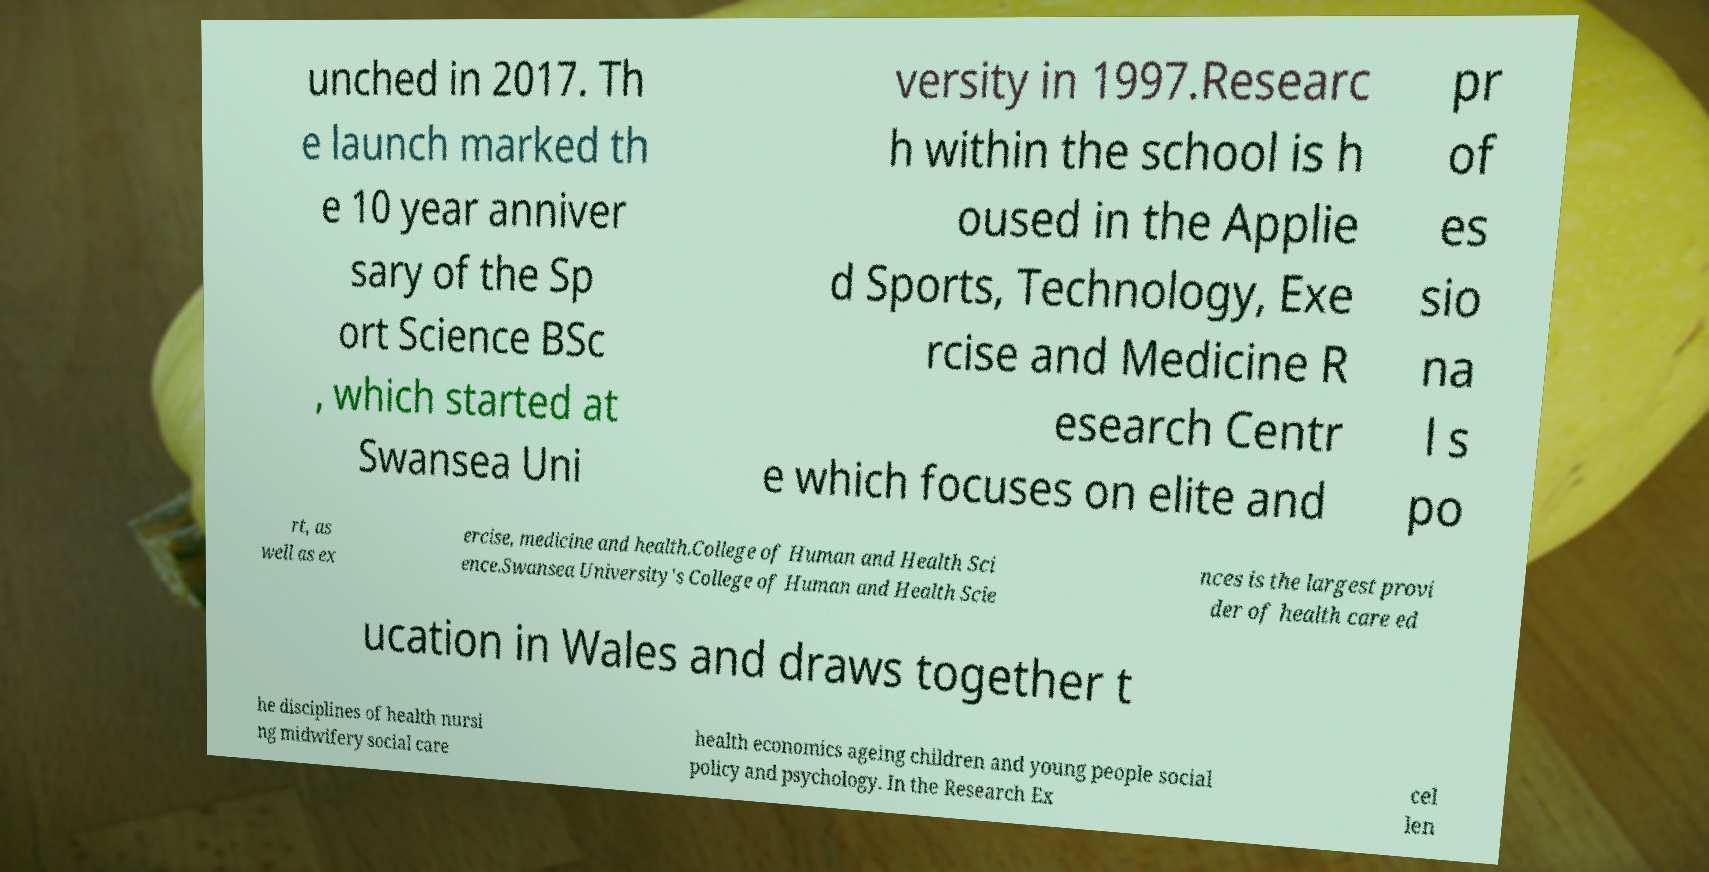For documentation purposes, I need the text within this image transcribed. Could you provide that? unched in 2017. Th e launch marked th e 10 year anniver sary of the Sp ort Science BSc , which started at Swansea Uni versity in 1997.Researc h within the school is h oused in the Applie d Sports, Technology, Exe rcise and Medicine R esearch Centr e which focuses on elite and pr of es sio na l s po rt, as well as ex ercise, medicine and health.College of Human and Health Sci ence.Swansea University's College of Human and Health Scie nces is the largest provi der of health care ed ucation in Wales and draws together t he disciplines of health nursi ng midwifery social care health economics ageing children and young people social policy and psychology. In the Research Ex cel len 